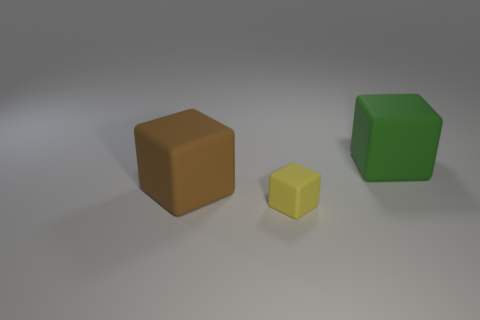Are there any large green metal cylinders?
Your answer should be very brief. No. What number of things are either large cyan blocks or big rubber blocks on the left side of the green block?
Provide a succinct answer. 1. There is a cube that is on the right side of the yellow block; does it have the same size as the small rubber block?
Provide a short and direct response. No. What number of other objects are there of the same size as the brown object?
Provide a succinct answer. 1. What is the color of the tiny object?
Ensure brevity in your answer.  Yellow. What is the thing that is on the left side of the small matte cube made of?
Your answer should be very brief. Rubber. Is the number of brown rubber cubes that are left of the brown rubber thing the same as the number of cubes?
Provide a short and direct response. No. Does the small rubber thing have the same shape as the big green thing?
Provide a short and direct response. Yes. Is there anything else that has the same color as the small cube?
Give a very brief answer. No. There is a matte object that is on the right side of the big brown cube and behind the small yellow cube; what is its shape?
Your answer should be very brief. Cube. 